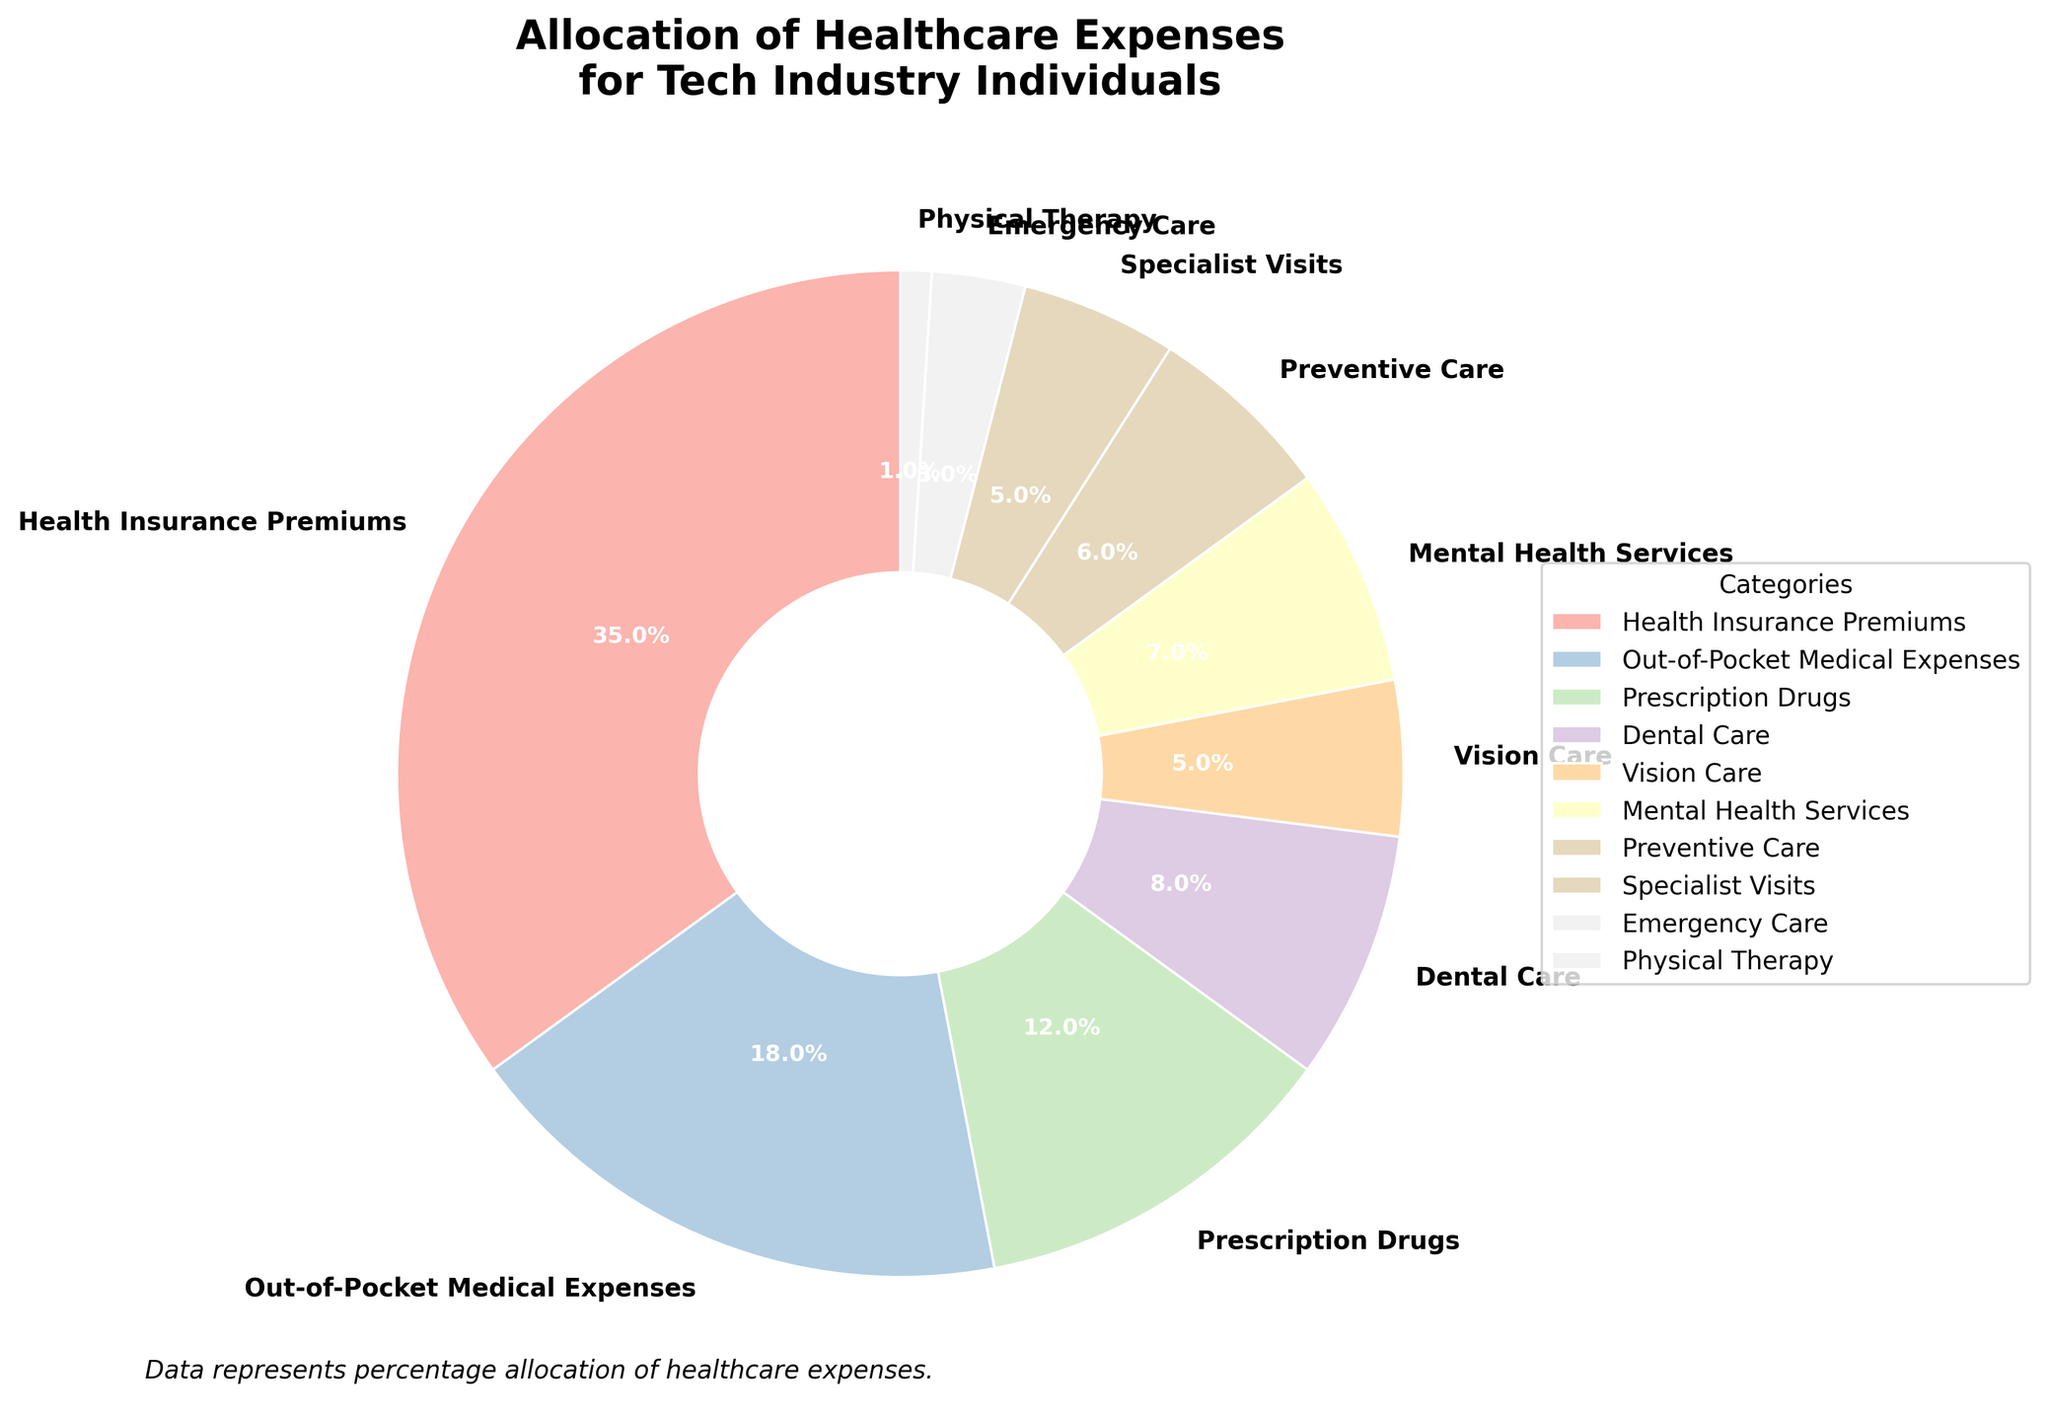How much of the total healthcare expenses are allocated to preventive care and mental health services combined? Look at the figure and find the percentages for preventive care and mental health services. Preventive care is 6% and mental health services is 7%. Add them together: 6% + 7% = 13%
Answer: 13% Which category receives the second highest allocation of healthcare expenses? Look at the pie chart and identify the second largest segment. Health insurance premiums have the highest at 35%, and the next largest segment is out-of-pocket medical expenses at 18%.
Answer: Out-of-Pocket Medical Expenses Is the percentage allocated to prescription drugs greater than the percentage allocated to dental care? Check the percentages in the pie chart for prescription drugs and dental care. Prescription drugs have 12%, and dental care has 8%. Since 12% > 8%, the answer is yes.
Answer: Yes What is the total percentage of expenses allocated to vision care and specialist visits? Look at the figure and find the percentages for vision care and specialist visits. Vision care is 5% and specialist visits is also 5%. Add them together: 5% + 5% = 10%
Answer: 10% Which category has the smallest allocation in the healthcare expenses? Identify the smallest segment in the pie chart. The smallest segment is for physical therapy at 1%.
Answer: Physical Therapy How much more is allocated to health insurance premiums compared to emergency care? Find the percentages for health insurance premiums and emergency care. Health insurance premiums have 35% and emergency care has 3%. Subtract the smaller percentage from the larger one: 35% - 3% = 32%
Answer: 32% What's the total percentage of out-of-pocket medical expenses, prescription drugs, and dental care combined? Look at the figure and find the percentages for these three categories: out-of-pocket medical expenses (18%), prescription drugs (12%), and dental care (8%). Add them together: 18% + 12% + 8% = 38%
Answer: 38% Compare the allocations for mental health services and preventive care. How do they differ? Find the percentages for mental health services and preventive care. Mental health services have 7% and preventive care has 6%. Subtract the smaller percentage from the larger one: 7% - 6% = 1%. Mental health services have 1% more allocation than preventive care.
Answer: 1% More What's the average percentage of expenses for vision care, specialist visits, and emergency care? Look at the figure and find the percentages for vision care (5%), specialist visits (5%), and emergency care (3%). Calculate the average by adding them and dividing by 3: (5% + 5% + 3%) / 3 = 4.33%
Answer: 4.33% Which three categories have the closest allocation percentages? Compare the percentages of all categories: dental care (8%), vision care (5%), mental health services (7%), preventive care (6%), specialist visits (5%), emergency care (3%), physical therapy (1%), out-of-pocket medical expenses (18%), prescription drugs (12%), health insurance premiums (35%). Vision care, specialist visits, and preventive care have the closest percentages (5%, 5%, and 6%).
Answer: Vision Care, Specialist Visits, Preventive Care 